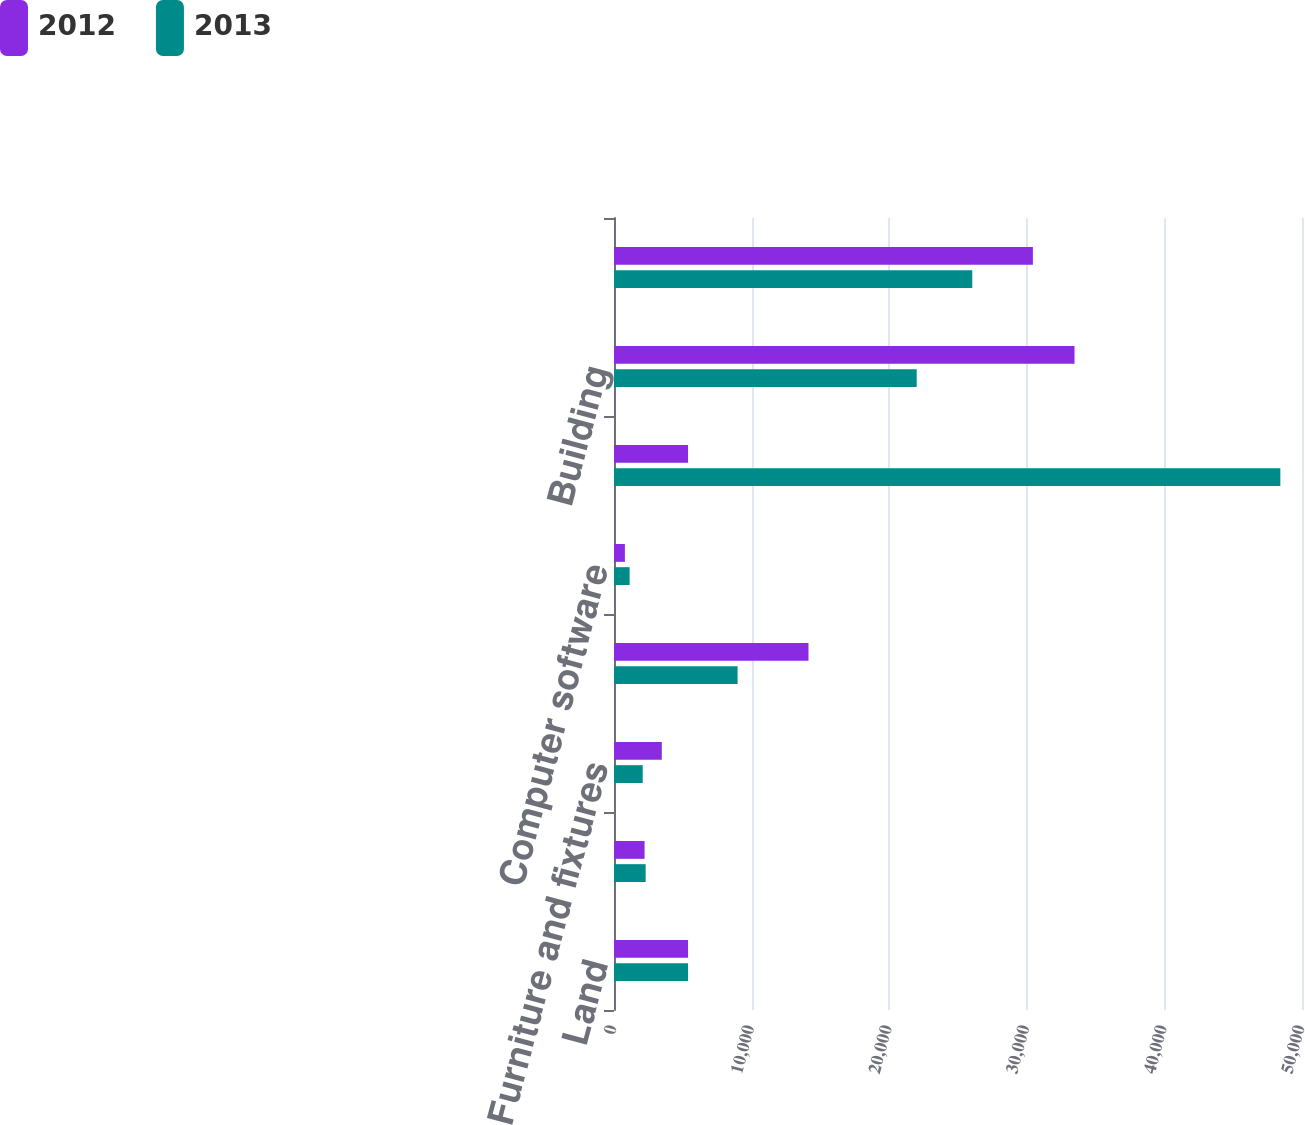Convert chart. <chart><loc_0><loc_0><loc_500><loc_500><stacked_bar_chart><ecel><fcel>Land<fcel>Leasehold improvements<fcel>Furniture and fixtures<fcel>Office and computer equipment<fcel>Computer software<fcel>Equipment<fcel>Building<fcel>Vehicles<nl><fcel>2012<fcel>5382<fcel>2222<fcel>3474<fcel>14135<fcel>791<fcel>5382<fcel>33468<fcel>30442<nl><fcel>2013<fcel>5382<fcel>2300<fcel>2087<fcel>8981<fcel>1135<fcel>48427<fcel>21998<fcel>26037<nl></chart> 